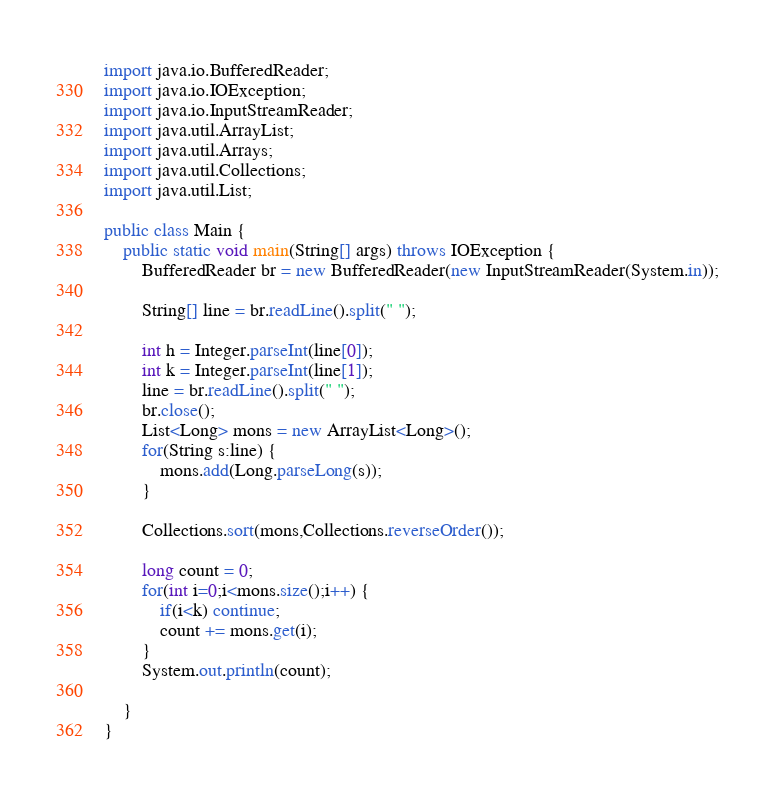<code> <loc_0><loc_0><loc_500><loc_500><_Java_>import java.io.BufferedReader;
import java.io.IOException;
import java.io.InputStreamReader;
import java.util.ArrayList;
import java.util.Arrays;
import java.util.Collections;
import java.util.List;

public class Main {
	public static void main(String[] args) throws IOException {
		BufferedReader br = new BufferedReader(new InputStreamReader(System.in));
		
		String[] line = br.readLine().split(" ");
		
		int h = Integer.parseInt(line[0]);
		int k = Integer.parseInt(line[1]);
		line = br.readLine().split(" ");
		br.close();
		List<Long> mons = new ArrayList<Long>();
		for(String s:line) {
			mons.add(Long.parseLong(s));
		}
		
		Collections.sort(mons,Collections.reverseOrder());
		
		long count = 0;
		for(int i=0;i<mons.size();i++) {
			if(i<k) continue;
			count += mons.get(i);
		}
		System.out.println(count);
		
	}
}
</code> 